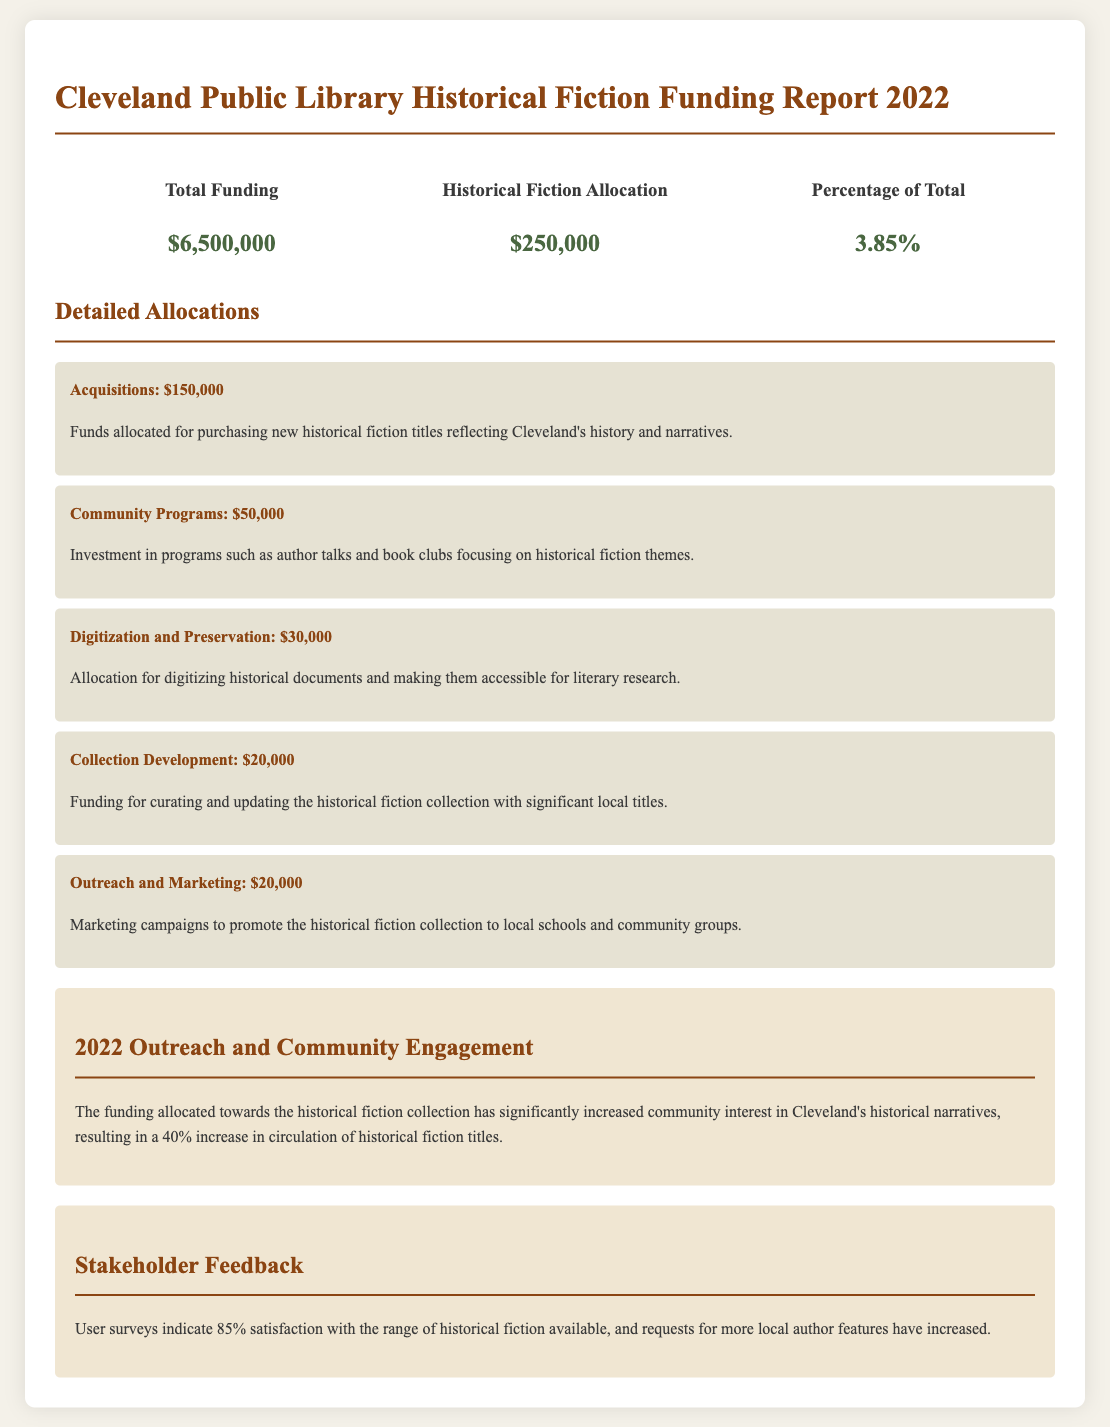What is the total funding for the Cleveland Public Library in 2022? The total funding is listed prominently in the document as $6,500,000.
Answer: $6,500,000 How much was allocated for historical fiction in 2022? The allocation for historical fiction is specified as $250,000 in the funding report.
Answer: $250,000 What percentage of the total funding is dedicated to historical fiction? The document states that the historical fiction allocation represents 3.85% of the total funding.
Answer: 3.85% How much was spent on acquisitions for historical fiction? The report details the allocation for acquisitions as $150,000, which is part of the historical fiction funding.
Answer: $150,000 What was the increase in circulation of historical fiction titles? A 40% increase in circulation of historical fiction titles is highlighted in the outreach section of the report.
Answer: 40% What is the allocated amount for community programs focusing on historical fiction? The document specifies that $50,000 was allocated for community programs related to historical fiction.
Answer: $50,000 Which specific area received the lowest allocation within the historical fiction funding? The collection development allocation of $20,000 is the lowest among the detailed allocations provided.
Answer: $20,000 What feedback percentage indicates satisfaction with the historical fiction range? The stakeholder feedback section mentions that 85% of users indicated satisfaction with the historical fiction available.
Answer: 85% How much funding was designated for outreach and marketing? The report indicates that $20,000 was allocated for outreach and marketing purposes.
Answer: $20,000 